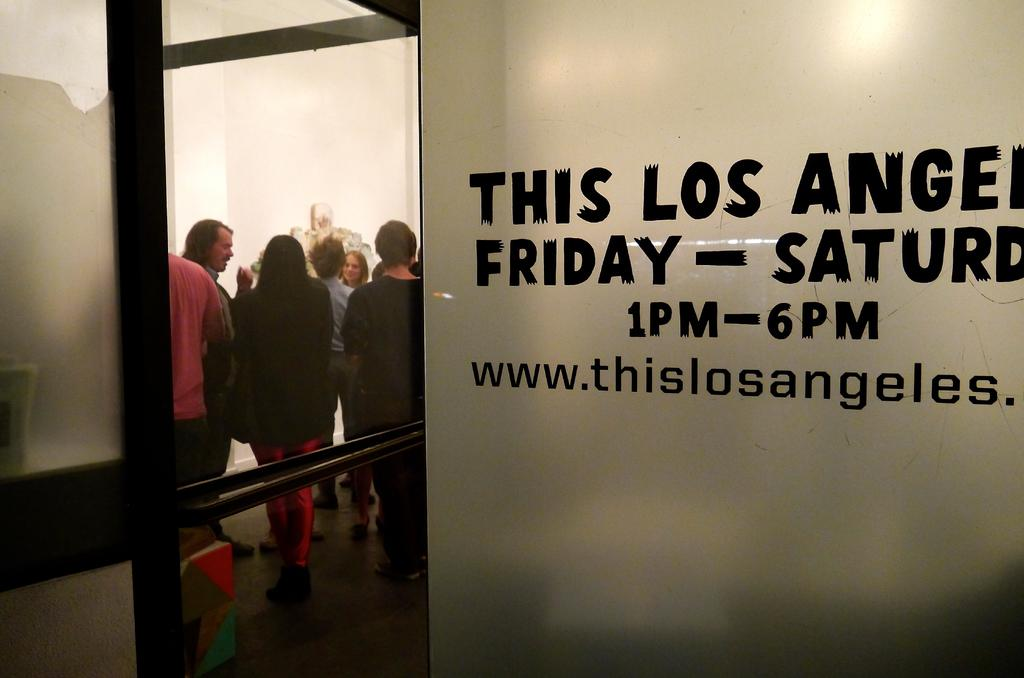<image>
Write a terse but informative summary of the picture. Inside of a Los Angeles office are people standing in a room 